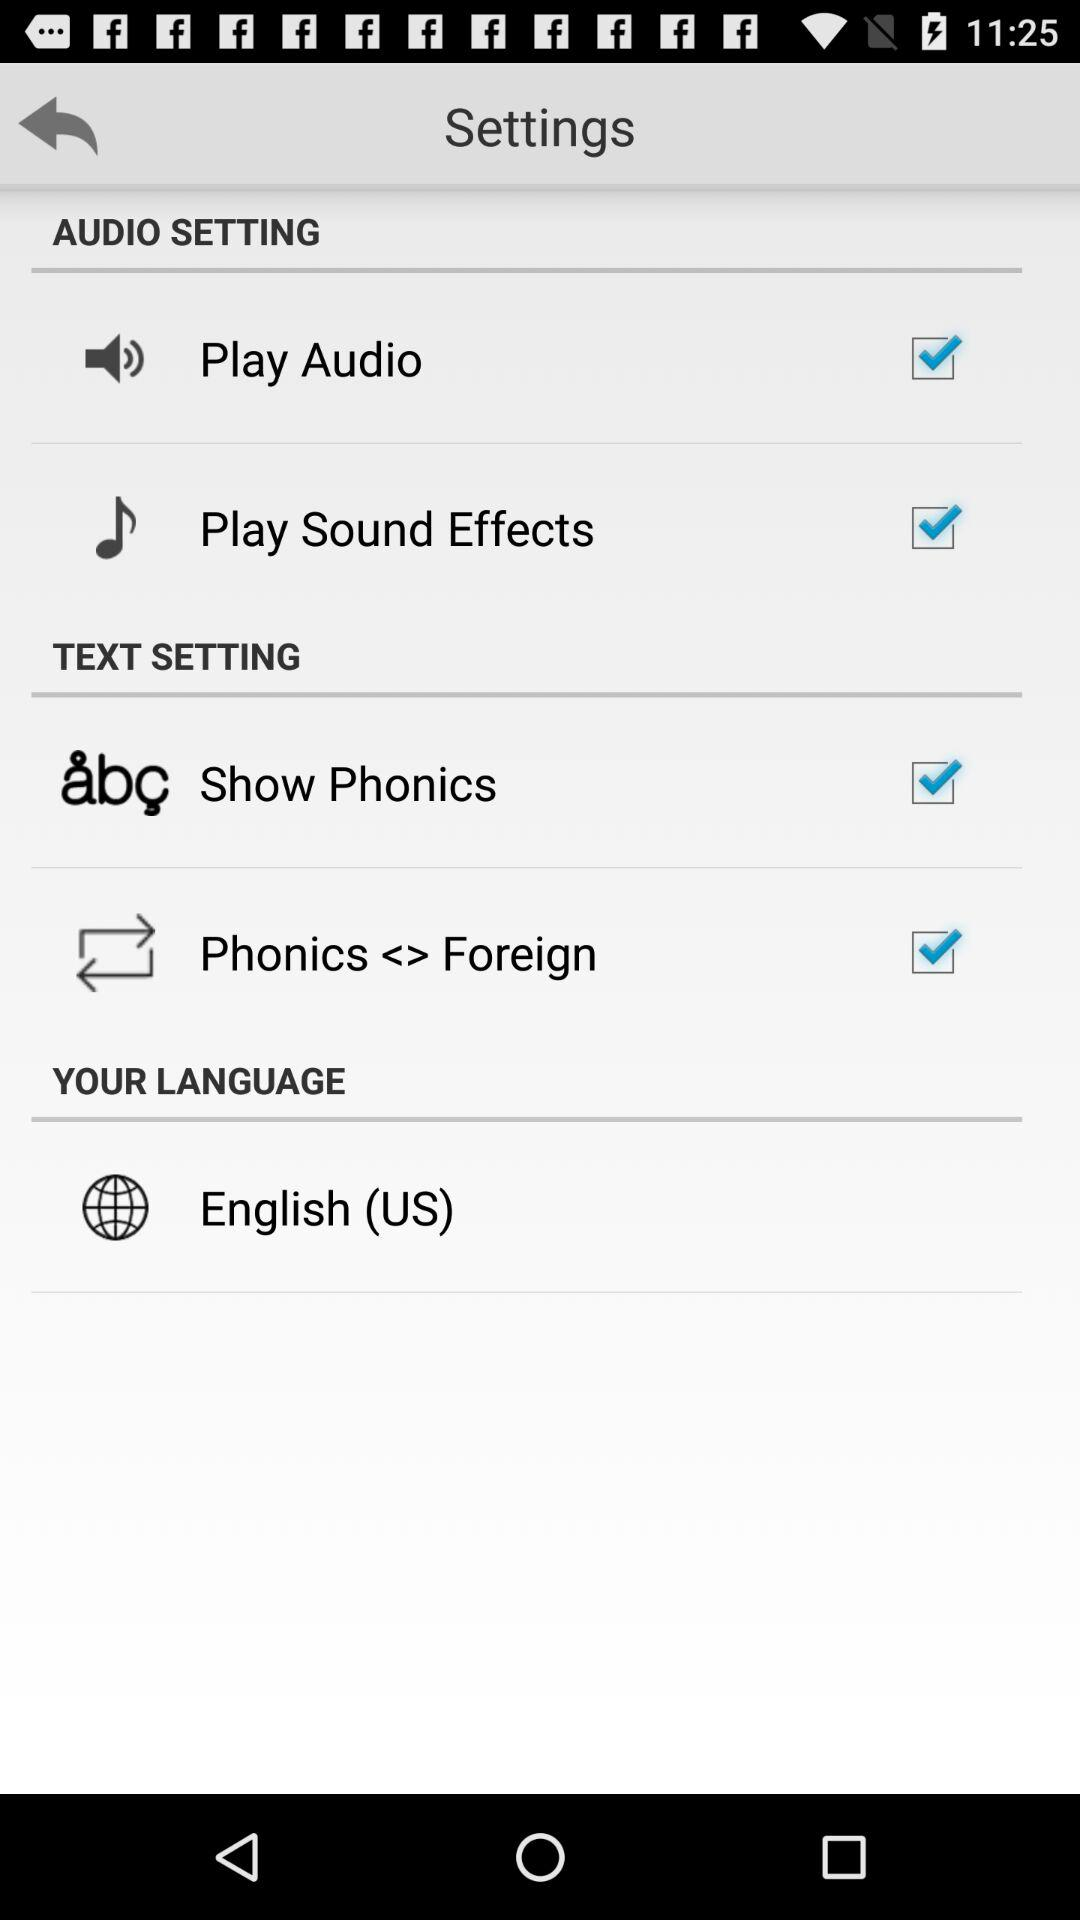What is the status of the "Play Sound Effects" setting? The status of the "Play Sound Effects" setting is "on". 